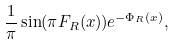<formula> <loc_0><loc_0><loc_500><loc_500>\frac { 1 } { \pi } \sin ( \pi F _ { R } ( x ) ) e ^ { - \Phi _ { R } ( x ) } ,</formula> 